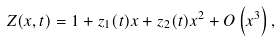<formula> <loc_0><loc_0><loc_500><loc_500>Z ( x , t ) = 1 + z _ { 1 } ( t ) x + z _ { 2 } ( t ) x ^ { 2 } + O \left ( x ^ { 3 } \right ) ,</formula> 